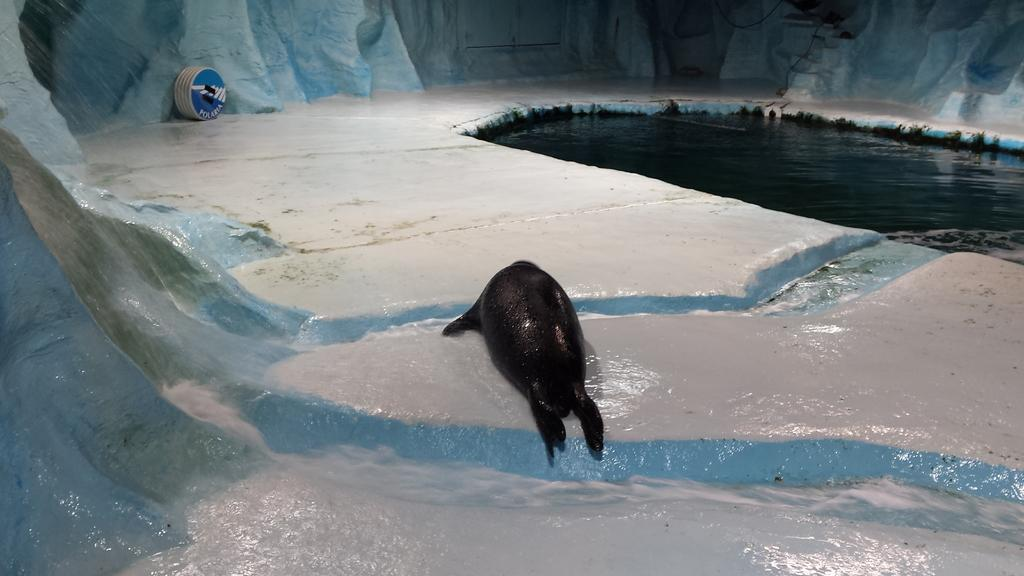What is located on the right side of the image? There is water on the right side of the image. What is the texture of the ice in the image? The ice in the image is solid. What animal can be seen on the ice? A seal is present on the ice. What is the shape of the object in the background of the image? There is a round object in the background of the image. What type of structure is visible in the image? There is an ice wall in the image. How does the seal contribute to the credit score in the image? There is no mention of credit scores or financial matters in the image, and the seal is an animal, not a person or entity that could have a credit score. 